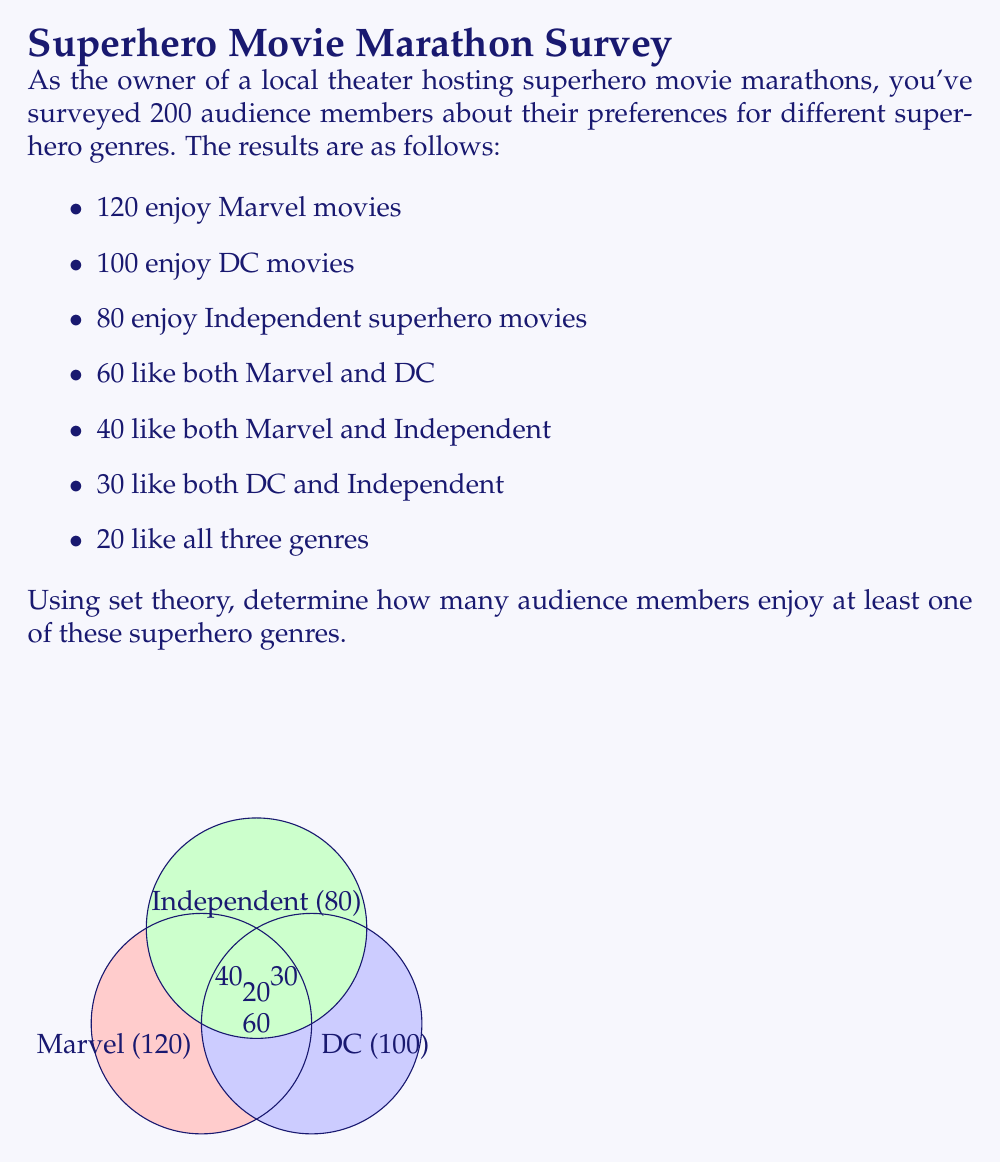What is the answer to this math problem? Let's approach this step-by-step using the principle of inclusion-exclusion:

1) Let M, D, and I represent the sets of people who enjoy Marvel, DC, and Independent superhero movies respectively.

2) We need to find $|M \cup D \cup I|$.

3) The principle of inclusion-exclusion states:

   $$|M \cup D \cup I| = |M| + |D| + |I| - |M \cap D| - |M \cap I| - |D \cap I| + |M \cap D \cap I|$$

4) We know:
   $|M| = 120$
   $|D| = 100$
   $|I| = 80$
   $|M \cap D| = 60$
   $|M \cap I| = 40$
   $|D \cap I| = 30$
   $|M \cap D \cap I| = 20$

5) Substituting these values:

   $$|M \cup D \cup I| = 120 + 100 + 80 - 60 - 40 - 30 + 20$$

6) Calculating:

   $$|M \cup D \cup I| = 300 - 130 + 20 = 190$$

Therefore, 190 audience members enjoy at least one of these superhero genres.
Answer: 190 